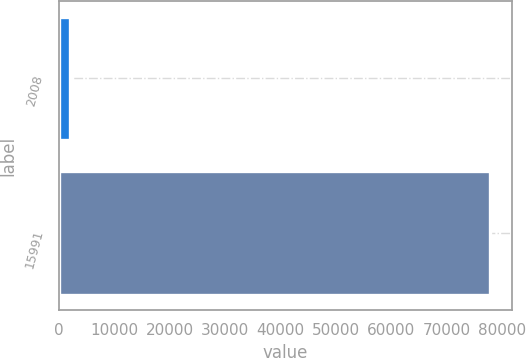<chart> <loc_0><loc_0><loc_500><loc_500><bar_chart><fcel>2008<fcel>15991<nl><fcel>2007<fcel>77882<nl></chart> 